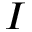Convert formula to latex. <formula><loc_0><loc_0><loc_500><loc_500>I</formula> 